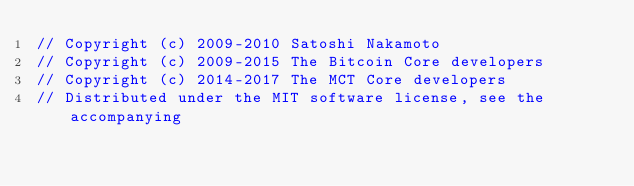<code> <loc_0><loc_0><loc_500><loc_500><_C_>// Copyright (c) 2009-2010 Satoshi Nakamoto
// Copyright (c) 2009-2015 The Bitcoin Core developers
// Copyright (c) 2014-2017 The MCT Core developers
// Distributed under the MIT software license, see the accompanying</code> 